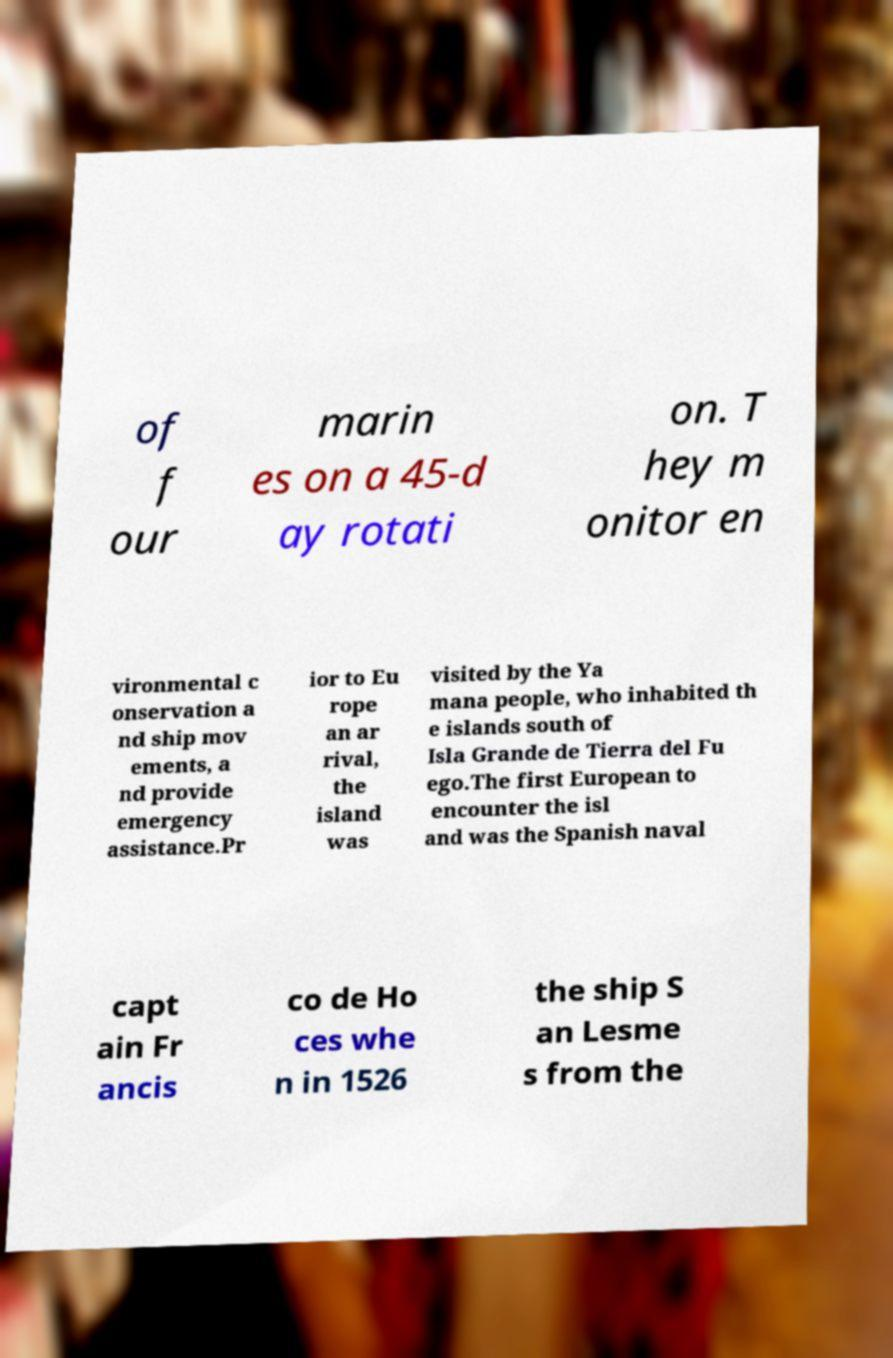Can you read and provide the text displayed in the image?This photo seems to have some interesting text. Can you extract and type it out for me? of f our marin es on a 45-d ay rotati on. T hey m onitor en vironmental c onservation a nd ship mov ements, a nd provide emergency assistance.Pr ior to Eu rope an ar rival, the island was visited by the Ya mana people, who inhabited th e islands south of Isla Grande de Tierra del Fu ego.The first European to encounter the isl and was the Spanish naval capt ain Fr ancis co de Ho ces whe n in 1526 the ship S an Lesme s from the 